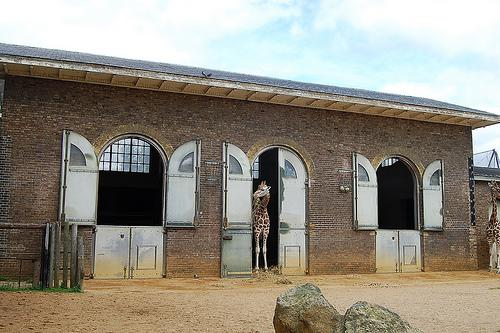Question: what animal is in the photo?
Choices:
A. Giraffe.
B. Cat.
C. Dog.
D. Horse.
Answer with the letter. Answer: A 